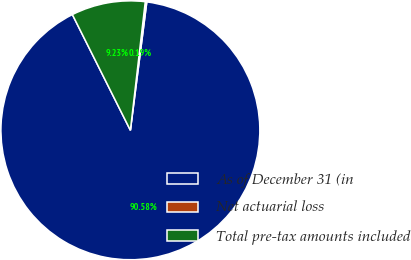Convert chart. <chart><loc_0><loc_0><loc_500><loc_500><pie_chart><fcel>As of December 31 (in<fcel>Net actuarial loss<fcel>Total pre-tax amounts included<nl><fcel>90.58%<fcel>0.19%<fcel>9.23%<nl></chart> 